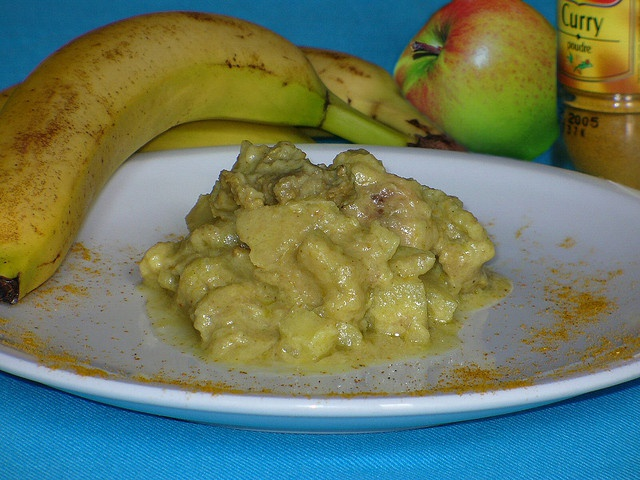Describe the objects in this image and their specific colors. I can see dining table in teal and olive tones, banana in teal, olive, and maroon tones, apple in teal and olive tones, and bottle in teal, olive, and black tones in this image. 